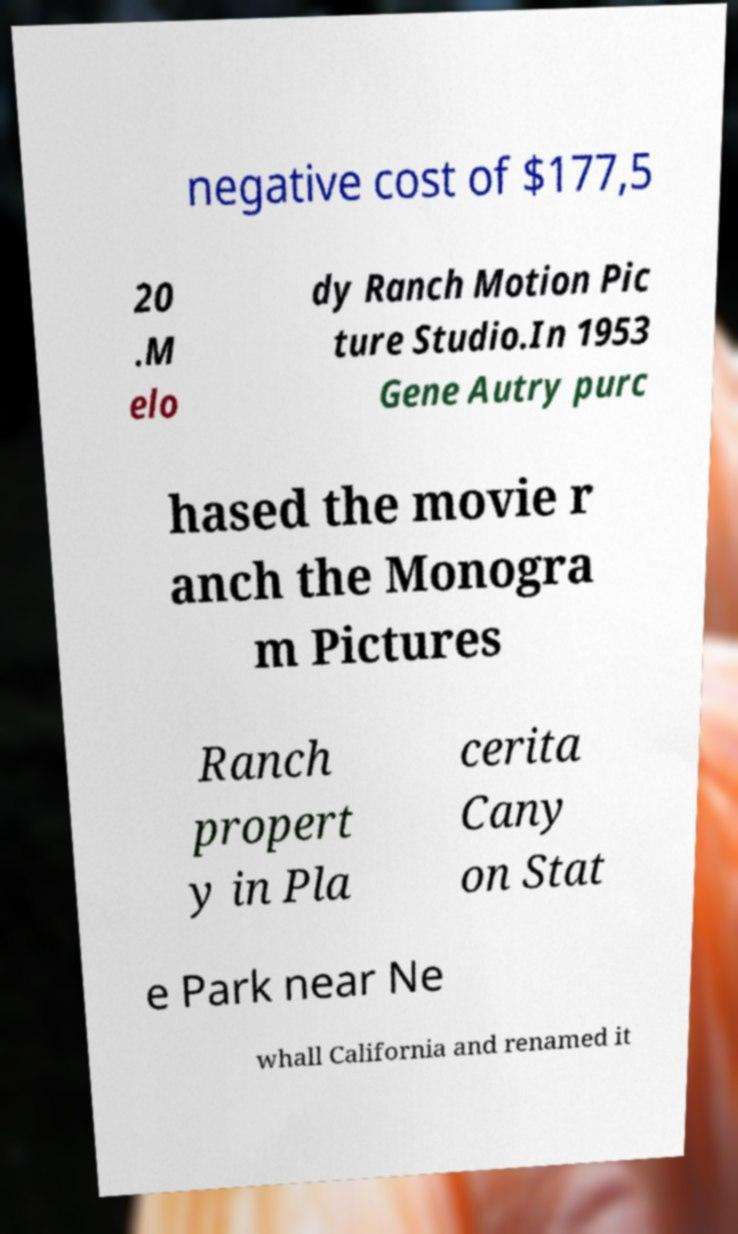Could you extract and type out the text from this image? negative cost of $177,5 20 .M elo dy Ranch Motion Pic ture Studio.In 1953 Gene Autry purc hased the movie r anch the Monogra m Pictures Ranch propert y in Pla cerita Cany on Stat e Park near Ne whall California and renamed it 